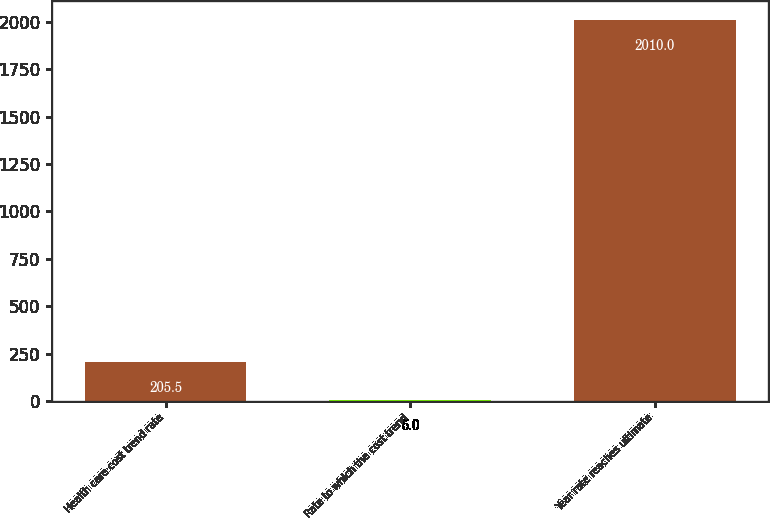Convert chart. <chart><loc_0><loc_0><loc_500><loc_500><bar_chart><fcel>Health care cost trend rate<fcel>Rate to which the cost trend<fcel>Year rate reaches ultimate<nl><fcel>205.5<fcel>5<fcel>2010<nl></chart> 